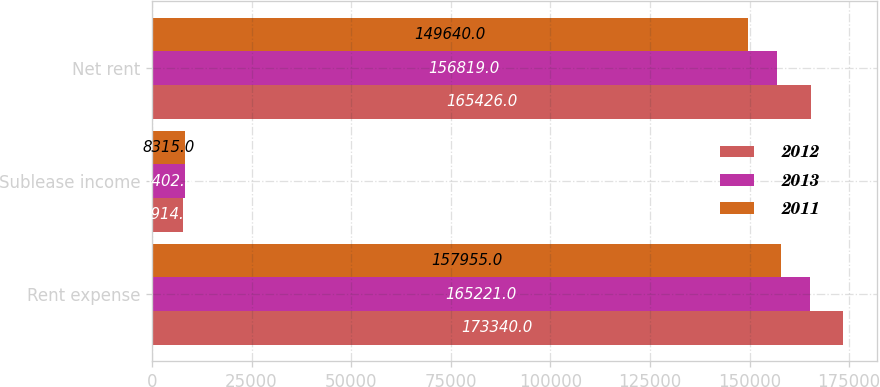Convert chart to OTSL. <chart><loc_0><loc_0><loc_500><loc_500><stacked_bar_chart><ecel><fcel>Rent expense<fcel>Sublease income<fcel>Net rent<nl><fcel>2012<fcel>173340<fcel>7914<fcel>165426<nl><fcel>2013<fcel>165221<fcel>8402<fcel>156819<nl><fcel>2011<fcel>157955<fcel>8315<fcel>149640<nl></chart> 